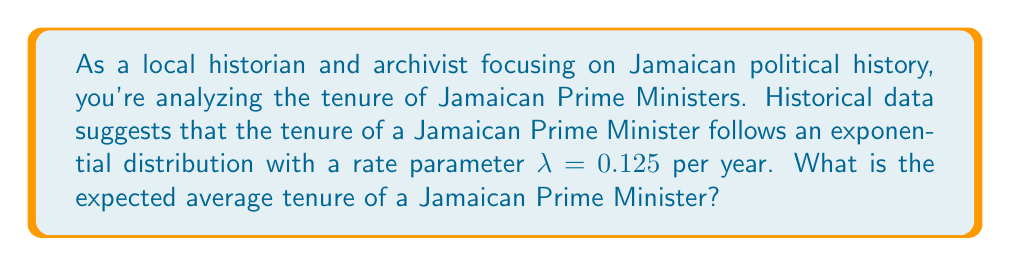What is the answer to this math problem? To solve this problem, we'll follow these steps:

1) Recall that for an exponential distribution with rate parameter $\lambda$, the expected value (mean) is given by:

   $$ E(X) = \frac{1}{\lambda} $$

2) We are given that $\lambda = 0.125$ per year.

3) Substituting this into our formula:

   $$ E(X) = \frac{1}{0.125} $$

4) Simplify:
   
   $$ E(X) = 8 $$

5) Therefore, the expected average tenure of a Jamaican Prime Minister is 8 years.

Note: The exponential distribution is often used to model the time until an event occurs, such as the end of a term in office. It assumes a constant rate of occurrence, which may be a simplification of real-world politics but can serve as a useful model for analysis.
Answer: 8 years 